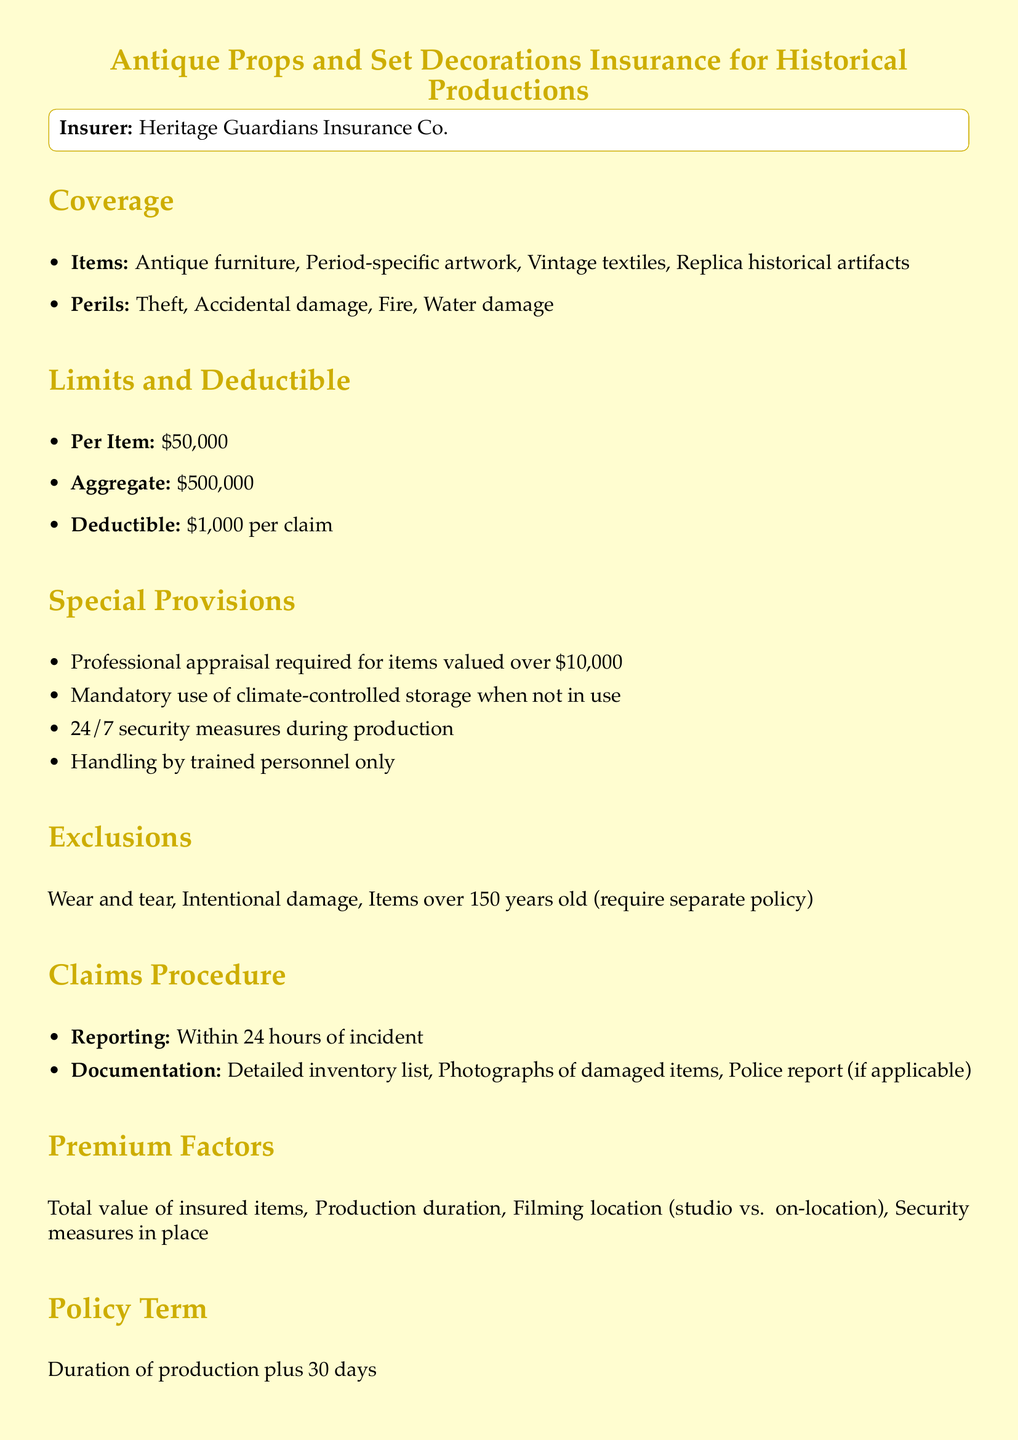What is the insurer's name? The insurer's name is stated clearly in the document as Heritage Guardians Insurance Co.
Answer: Heritage Guardians Insurance Co What types of items are covered? The document lists specific types of items included in coverage, such as antique furniture and vintage textiles.
Answer: Antique furniture, Period-specific artwork, Vintage textiles, Replica historical artifacts What is the deductible amount? The document specifies a deductible that must be paid before the insurance coverage takes effect for claims.
Answer: $1,000 per claim What is the value limit per item? The policy states the maximum coverage amount allowed for each insured item, indicating its value limit.
Answer: $50,000 Is professional appraisal required? The document mentions that a professional appraisal is necessary, but only for items exceeding a certain value.
Answer: Yes, for items valued over $10,000 What is the policy duration? The document defines how long the insurance coverage will last in relation to the production timeline.
Answer: Duration of production plus 30 days What are the exclusion criteria? The policy outlines certain conditions under which coverage will not apply, including specific item age.
Answer: Wear and tear, Intentional damage, Items over 150 years old How quickly must claims be reported? The document prescribes a specific time frame in which claims need to be reported following an incident.
Answer: Within 24 hours of incident What security measures are mandated during production? Security measures mentioned ensure the safety of items while being used on set, highlighting the necessary precautions.
Answer: 24/7 security measures during production 